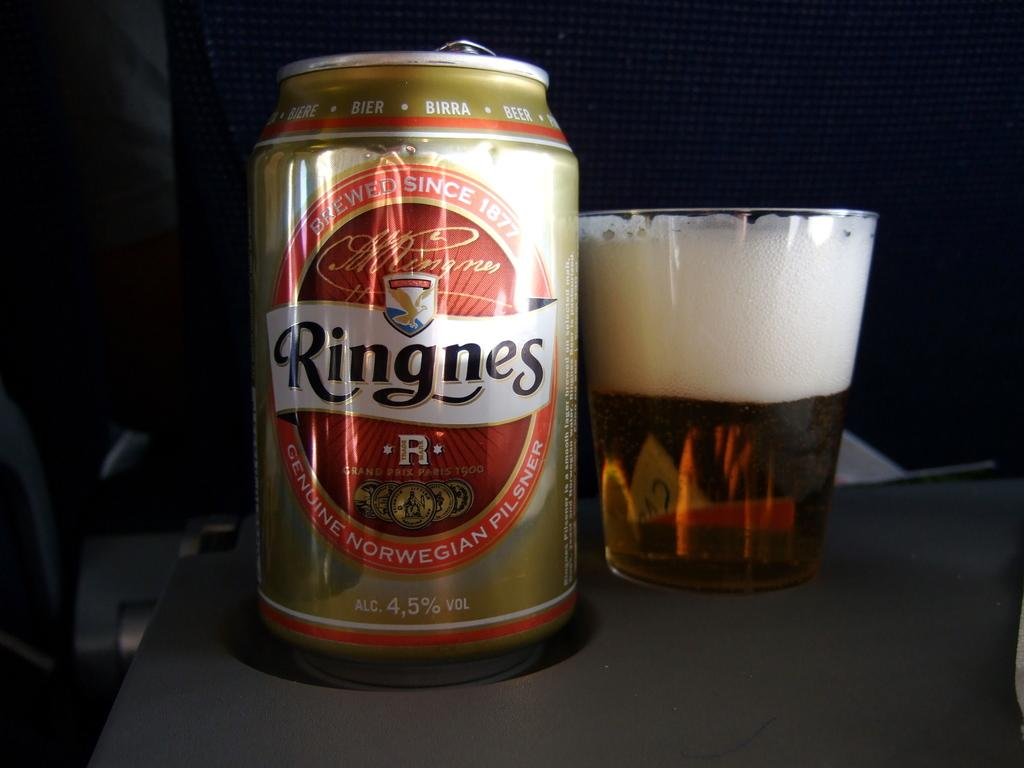<image>
Create a compact narrative representing the image presented. bottle of beer the brand is ringnes and filled cup 